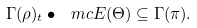<formula> <loc_0><loc_0><loc_500><loc_500>\Gamma ( \rho ) _ { t } \bullet \ m c { E } ( \Theta ) \subseteq \Gamma ( \pi ) .</formula> 